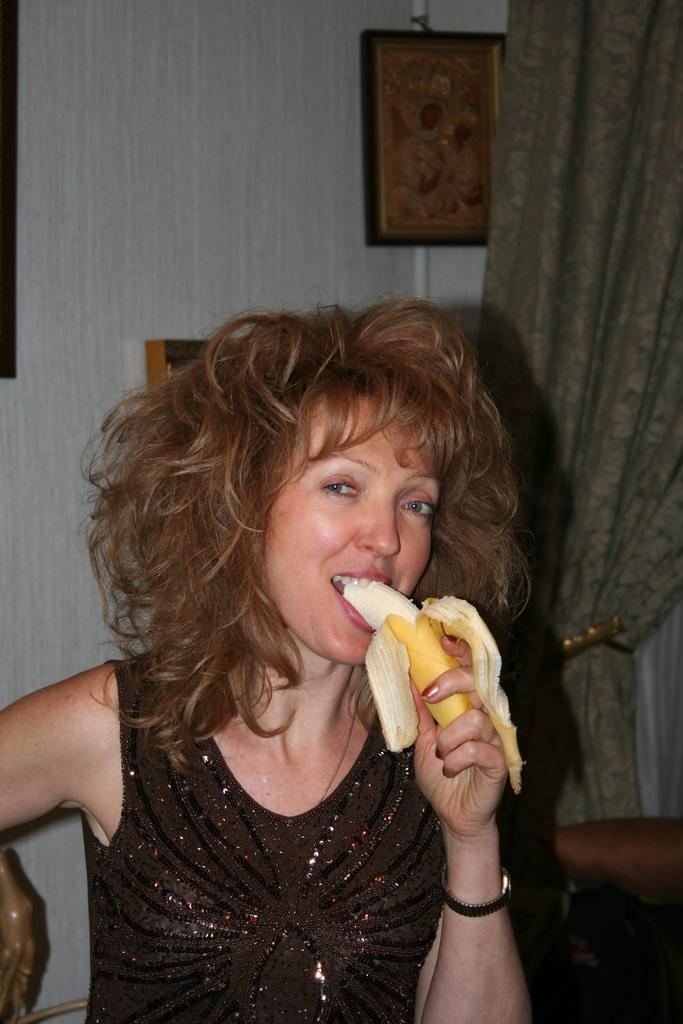Who is the main subject in the image? There is a lady in the center of the image. What is the lady holding in the image? The lady is holding a banana. What can be seen in the background of the image? There is a frame and a curtain in the background of the image. Can you describe the object on the wall in the background? There is an object on the wall in the background of the image, but its specific details are not mentioned in the facts. How many snakes are slithering on the floor in the image? There are no snakes present in the image. What type of scissors can be seen in the lady's hand in the image? The lady is holding a banana, not scissors, in the image. 